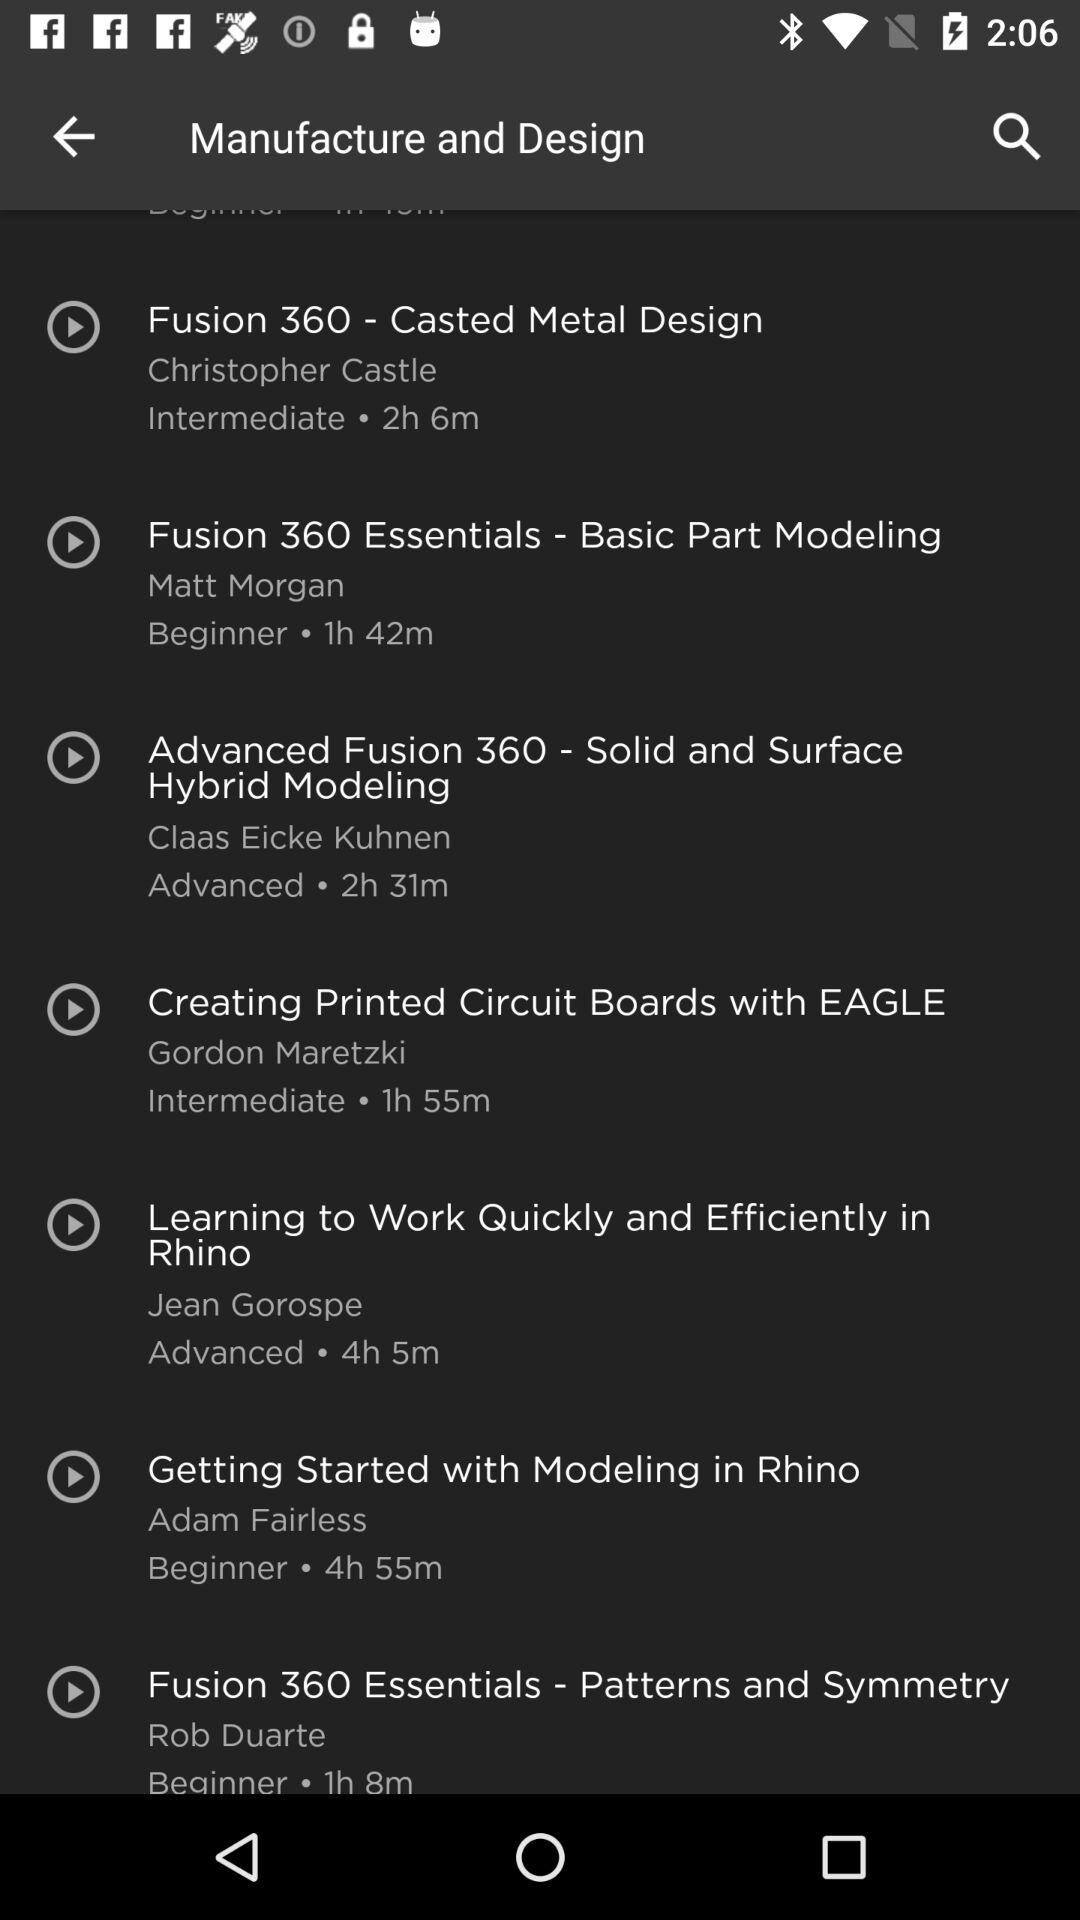Who is the instructor of the course "Fusion 360 Essentials - Basic Part Modeling"? The instructor of the course "Fusion 360 Essentials - Basic Part Modeling" is Matt Morgan. 